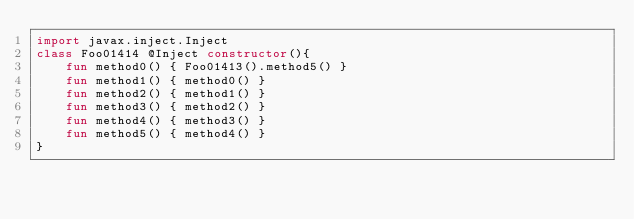Convert code to text. <code><loc_0><loc_0><loc_500><loc_500><_Kotlin_>import javax.inject.Inject
class Foo01414 @Inject constructor(){
    fun method0() { Foo01413().method5() }
    fun method1() { method0() }
    fun method2() { method1() }
    fun method3() { method2() }
    fun method4() { method3() }
    fun method5() { method4() }
}
</code> 